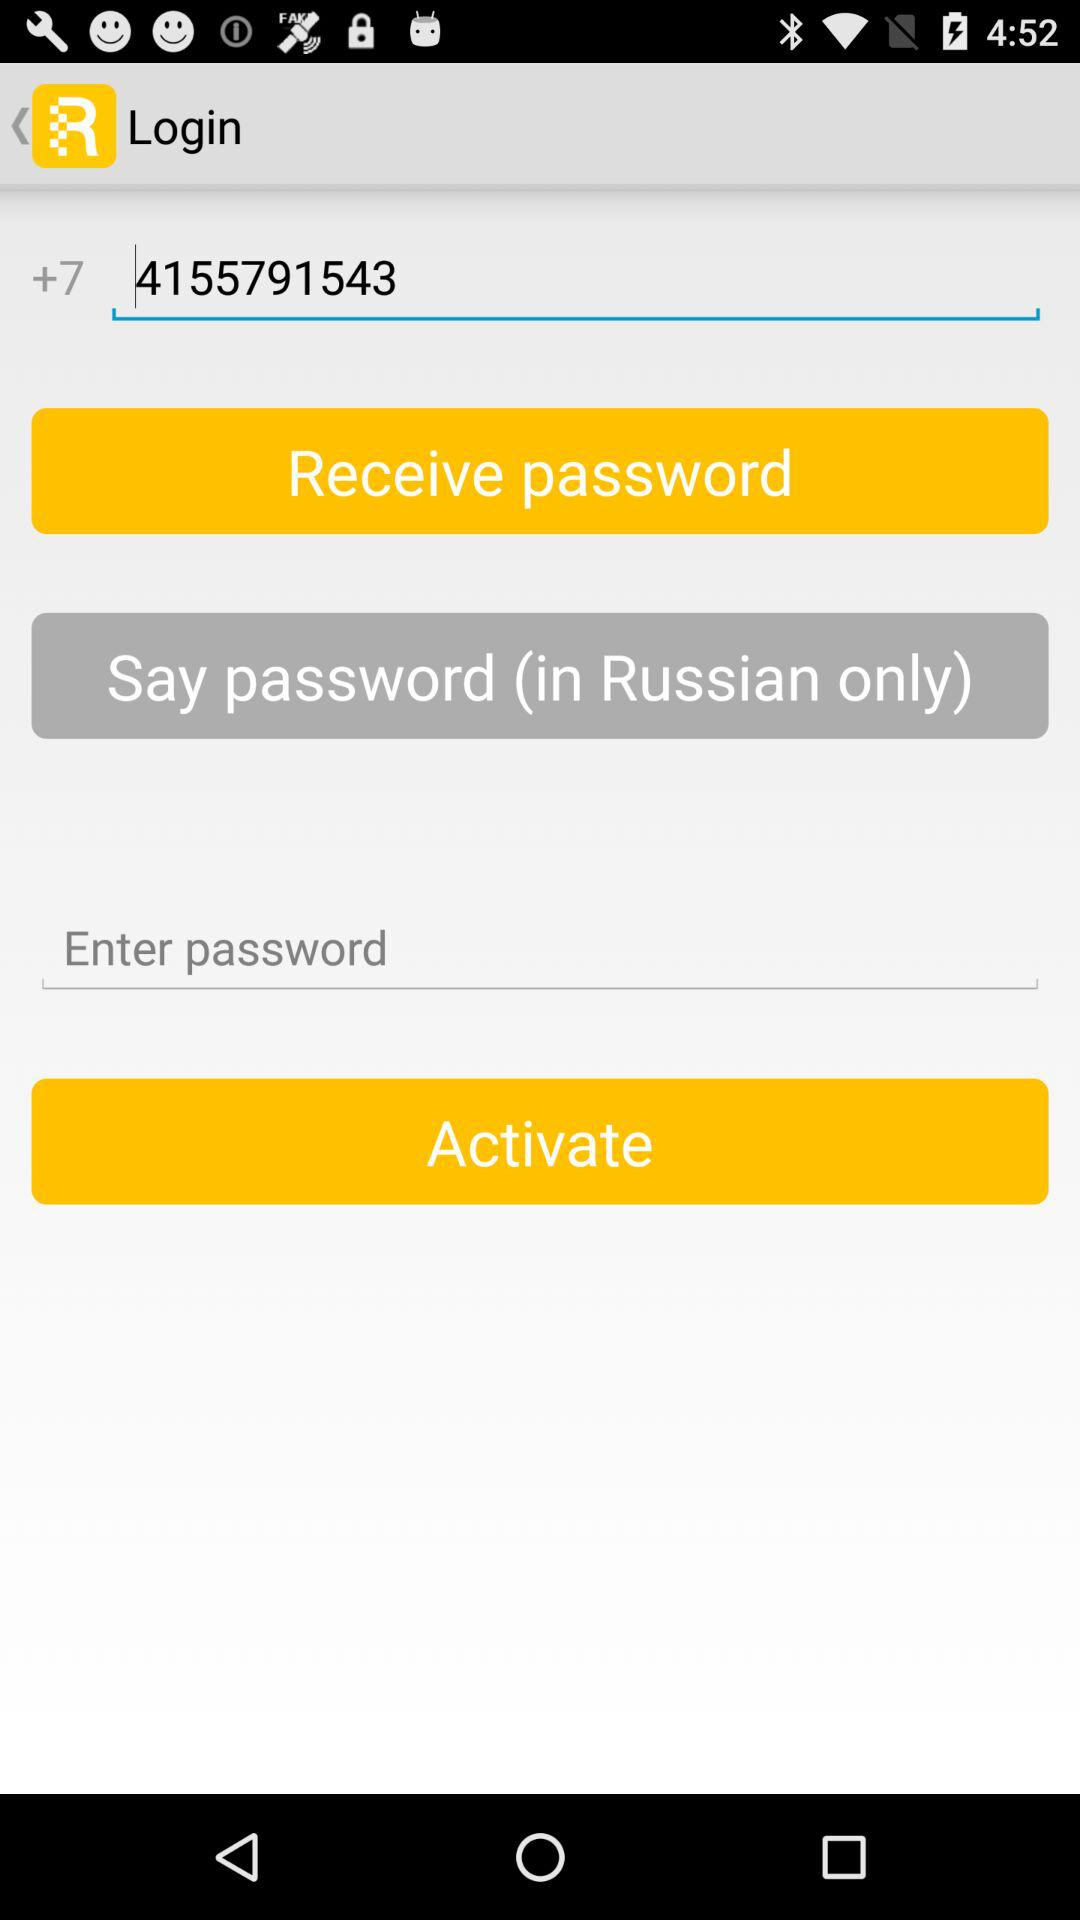What is the contact number? The contact number is +74155791543. 